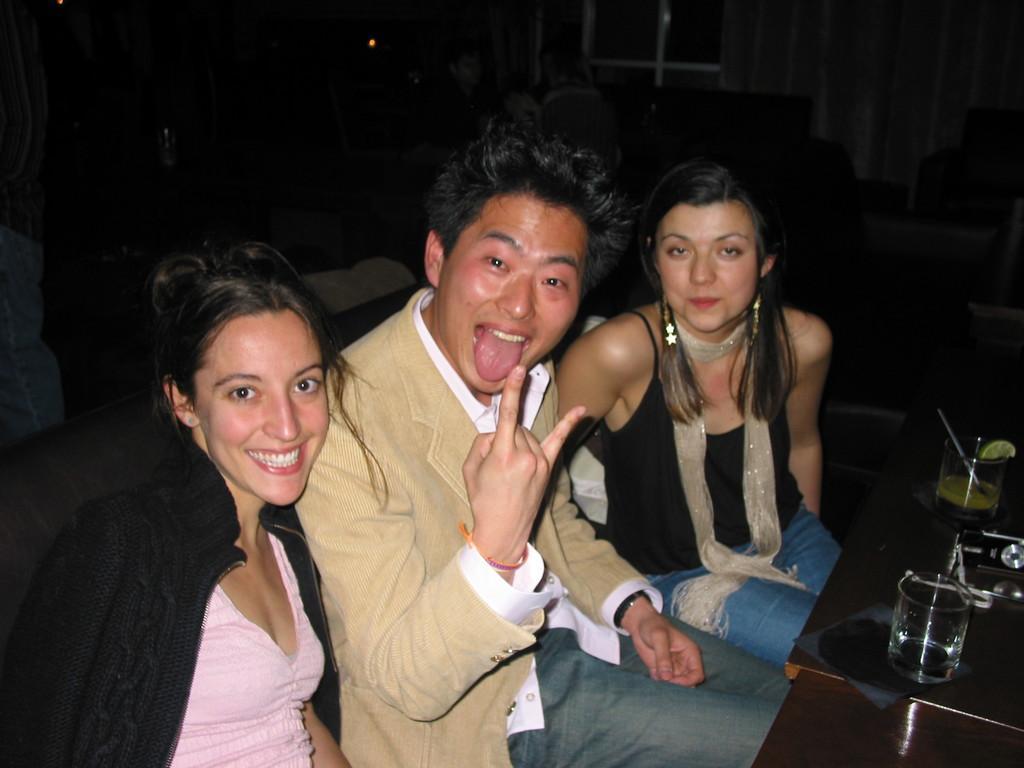Could you give a brief overview of what you see in this image? There are three members sitting in this picture. Two of them were women and middle one was man. All of them were smiling. In front of them there is a table on which some glasses and spoons were there. In the background there is a window and a curtain here. 